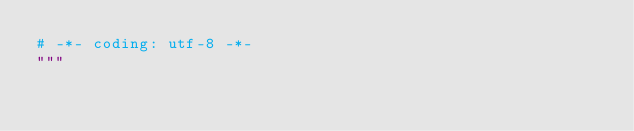<code> <loc_0><loc_0><loc_500><loc_500><_Python_># -*- coding: utf-8 -*-
"""</code> 